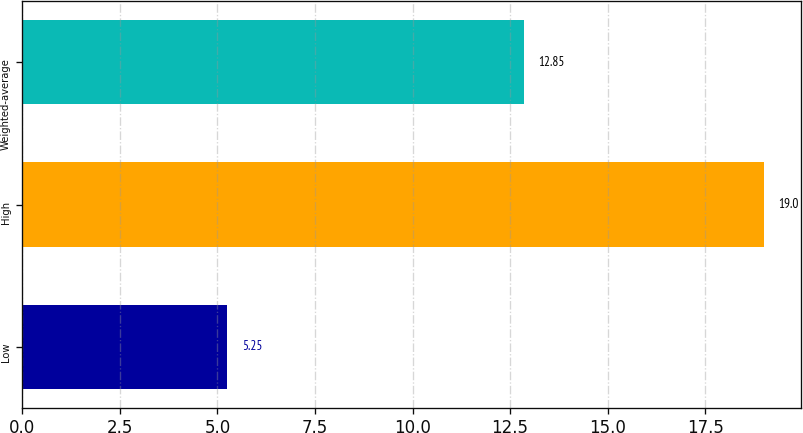Convert chart. <chart><loc_0><loc_0><loc_500><loc_500><bar_chart><fcel>Low<fcel>High<fcel>Weighted-average<nl><fcel>5.25<fcel>19<fcel>12.85<nl></chart> 